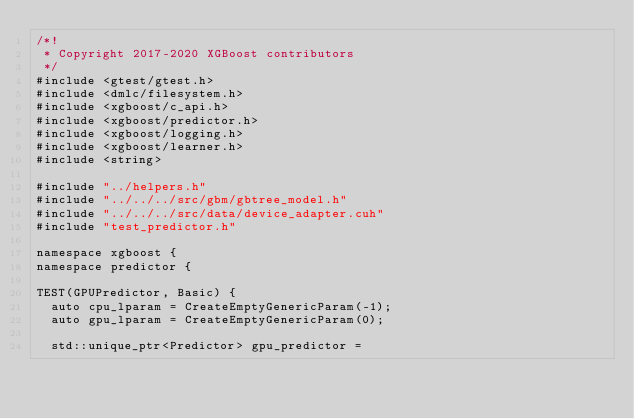<code> <loc_0><loc_0><loc_500><loc_500><_Cuda_>/*!
 * Copyright 2017-2020 XGBoost contributors
 */
#include <gtest/gtest.h>
#include <dmlc/filesystem.h>
#include <xgboost/c_api.h>
#include <xgboost/predictor.h>
#include <xgboost/logging.h>
#include <xgboost/learner.h>
#include <string>

#include "../helpers.h"
#include "../../../src/gbm/gbtree_model.h"
#include "../../../src/data/device_adapter.cuh"
#include "test_predictor.h"

namespace xgboost {
namespace predictor {

TEST(GPUPredictor, Basic) {
  auto cpu_lparam = CreateEmptyGenericParam(-1);
  auto gpu_lparam = CreateEmptyGenericParam(0);

  std::unique_ptr<Predictor> gpu_predictor =</code> 